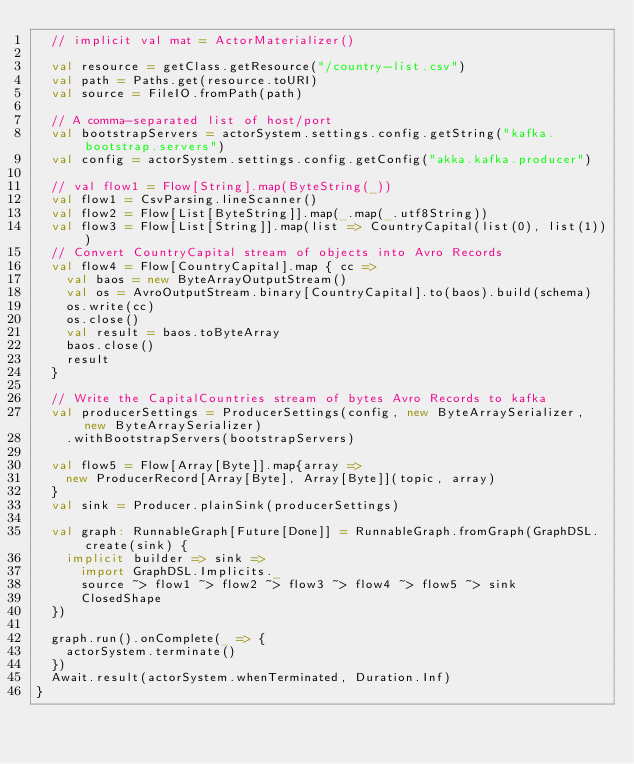Convert code to text. <code><loc_0><loc_0><loc_500><loc_500><_Scala_>  // implicit val mat = ActorMaterializer()

  val resource = getClass.getResource("/country-list.csv")
  val path = Paths.get(resource.toURI)
  val source = FileIO.fromPath(path)

  // A comma-separated list of host/port
  val bootstrapServers = actorSystem.settings.config.getString("kafka.bootstrap.servers")
  val config = actorSystem.settings.config.getConfig("akka.kafka.producer")

  // val flow1 = Flow[String].map(ByteString(_))
  val flow1 = CsvParsing.lineScanner()
  val flow2 = Flow[List[ByteString]].map(_.map(_.utf8String))
  val flow3 = Flow[List[String]].map(list => CountryCapital(list(0), list(1)))
  // Convert CountryCapital stream of objects into Avro Records
  val flow4 = Flow[CountryCapital].map { cc =>
    val baos = new ByteArrayOutputStream()
    val os = AvroOutputStream.binary[CountryCapital].to(baos).build(schema)
    os.write(cc)
    os.close()
    val result = baos.toByteArray
    baos.close()
    result
  }

  // Write the CapitalCountries stream of bytes Avro Records to kafka
  val producerSettings = ProducerSettings(config, new ByteArraySerializer, new ByteArraySerializer)
    .withBootstrapServers(bootstrapServers)

  val flow5 = Flow[Array[Byte]].map{array =>
    new ProducerRecord[Array[Byte], Array[Byte]](topic, array)
  }
  val sink = Producer.plainSink(producerSettings)

  val graph: RunnableGraph[Future[Done]] = RunnableGraph.fromGraph(GraphDSL.create(sink) {
    implicit builder => sink =>
      import GraphDSL.Implicits._
      source ~> flow1 ~> flow2 ~> flow3 ~> flow4 ~> flow5 ~> sink
      ClosedShape
  })

  graph.run().onComplete(_ => {
    actorSystem.terminate()
  })
  Await.result(actorSystem.whenTerminated, Duration.Inf)
}
</code> 